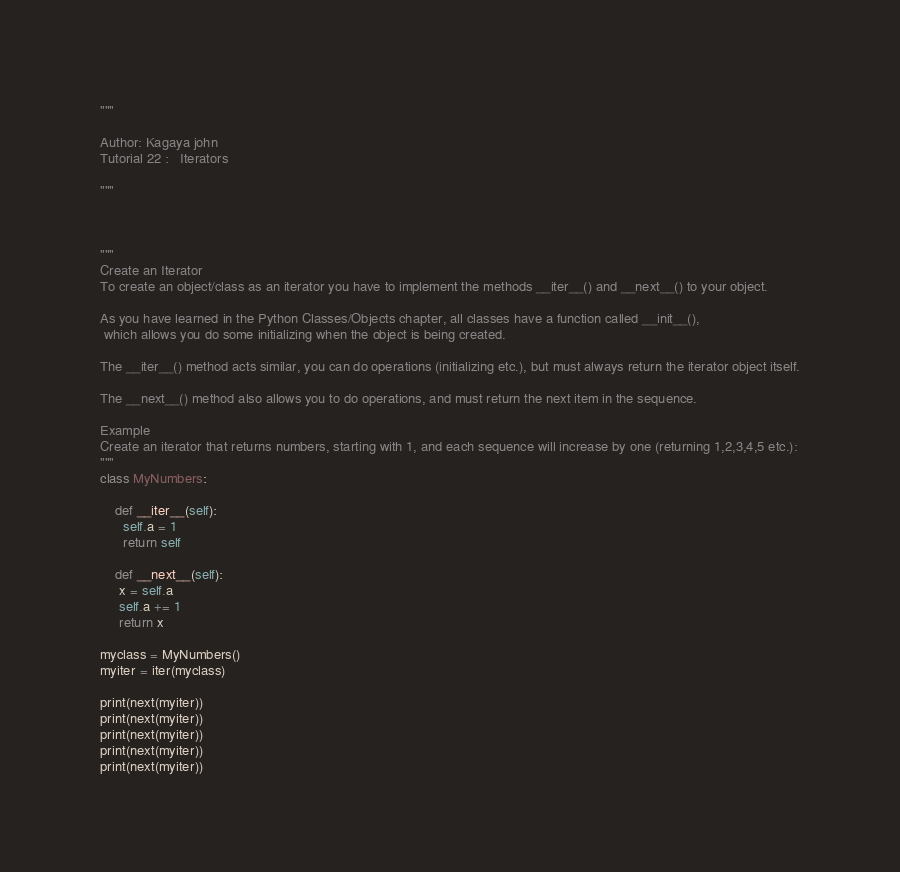<code> <loc_0><loc_0><loc_500><loc_500><_Python_>"""

Author: Kagaya john 
Tutorial 22 :   Iterators

"""



"""
Create an Iterator
To create an object/class as an iterator you have to implement the methods __iter__() and __next__() to your object.

As you have learned in the Python Classes/Objects chapter, all classes have a function called __init__(),
 which allows you do some initializing when the object is being created.

The __iter__() method acts similar, you can do operations (initializing etc.), but must always return the iterator object itself.

The __next__() method also allows you to do operations, and must return the next item in the sequence.

Example
Create an iterator that returns numbers, starting with 1, and each sequence will increase by one (returning 1,2,3,4,5 etc.):
"""
class MyNumbers:

    def __iter__(self):
      self.a = 1
      return self

    def __next__(self):
     x = self.a
     self.a += 1
     return x

myclass = MyNumbers()
myiter = iter(myclass)

print(next(myiter))
print(next(myiter))
print(next(myiter))
print(next(myiter))
print(next(myiter))
</code> 